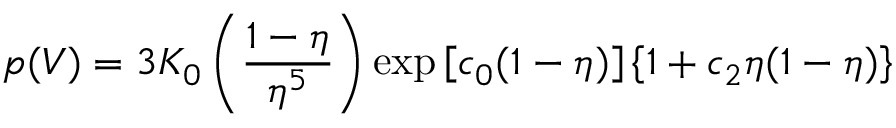<formula> <loc_0><loc_0><loc_500><loc_500>p ( V ) = 3 K _ { 0 } \left ( { \frac { 1 - \eta } { \eta ^ { 5 } } } \right ) \exp \left [ c _ { 0 } ( 1 - \eta ) \right ] \left \{ 1 + c _ { 2 } \eta ( 1 - \eta ) \right \}</formula> 